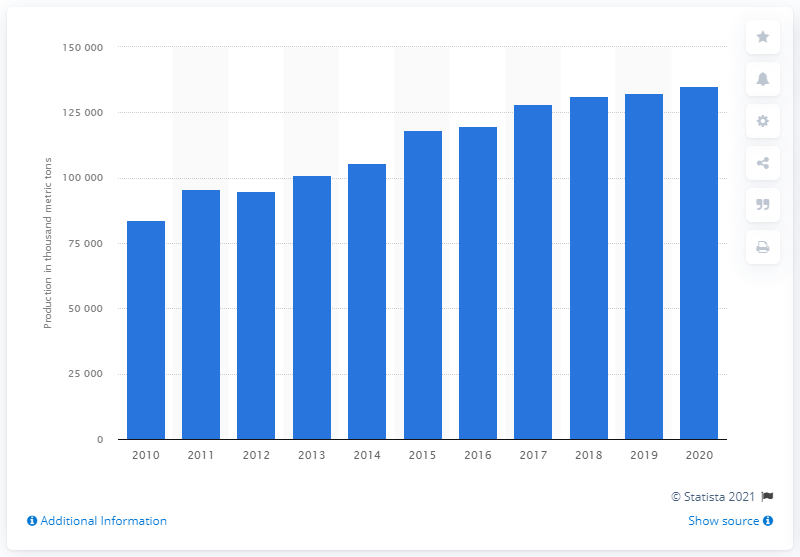Outline some significant characteristics in this image. In 2020, the global production of alumina reached 135 million metric tons. 